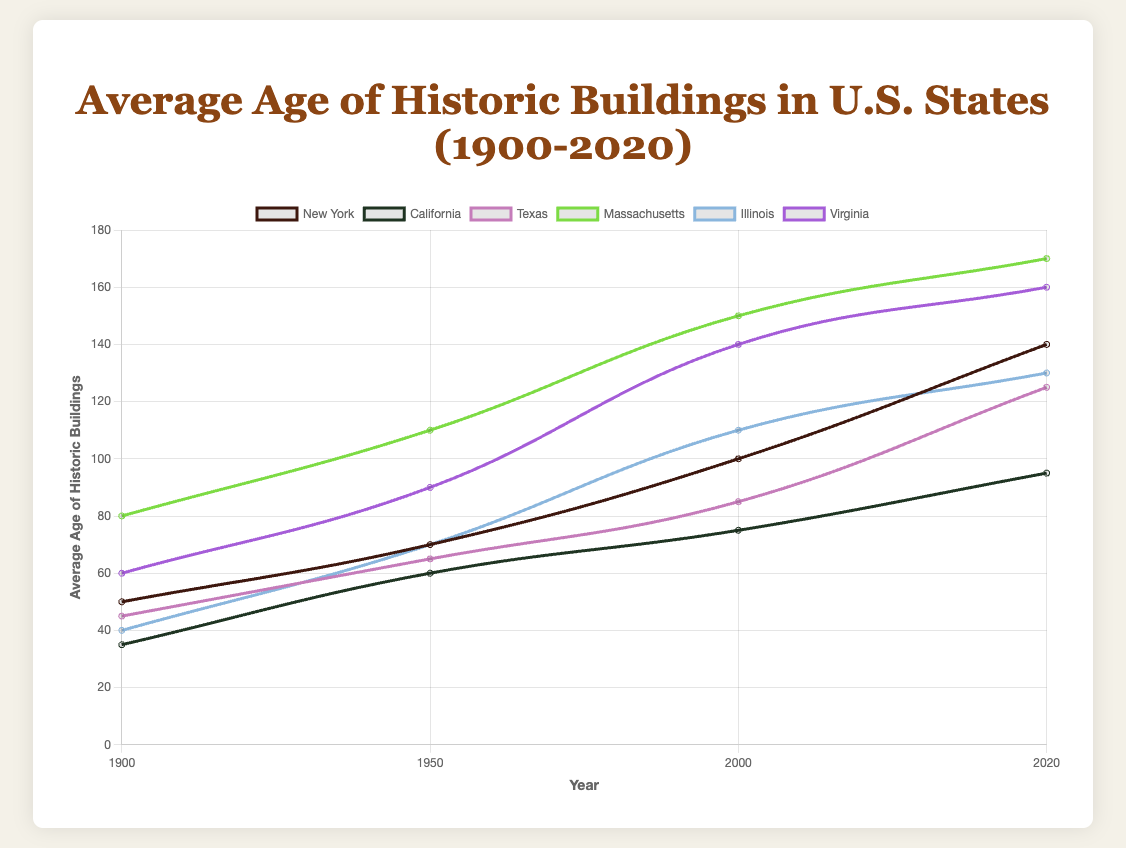What is the average age of historic buildings in New York in 2000? The figure shows a data point for New York in the year 2000, where the average age is marked.
Answer: 100 Which state had the oldest average age of historic buildings in 2020? By examining the data points for the year 2020 and comparing their values, Massachusetts has the highest value of 170.
Answer: Massachusetts How did the average age of historic buildings in Illinois change from 1900 to 2020? Look at the data points for Illinois in 1900 and then in 2020. The value changes from 40 to 130.
Answer: Increased by 90 Which state showed the most significant increase in the average age of historic buildings between 1900 and 2020? By looking at the difference in average ages from 1900 to 2020 for all states, New York increased from 50 to 140, which is an increase of 90, the largest among all states.
Answer: New York What is the difference in the average age of historic buildings between Massachusetts and California in 2020? For the year 2020, Massachusetts is at 170, and California is at 95. The difference is 170 - 95.
Answer: 75 How did the average age of historic buildings in Virginia evolve from 1950 to 2000? Check the data points for Virginia in 1950 and 2000. The average age grew from 90 to 140.
Answer: Increased by 50 Which state had the youngest average age of historic buildings in 1950? Looking at the data for 1950, California had the lowest average age of 60.
Answer: California What is the combined average age of historic buildings in Texas and New York in 2020? In 2020, Texas has an average age of 125, and New York has 140. The combined average is (125 + 140) / 2.
Answer: 132.5 Which state had the least change in the average age of historic buildings from 2000 to 2020? Calculate the difference for each state between 2000 and 2020 and identify the smallest. California changed from 75 to 95, a difference of 20, which is the smallest.
Answer: California Between 1900 and 1950, which state had the highest rate of increase in the average age of historic buildings? Calculate the rate of increase for each state between 1900 and 1950: (increase in average age) / (number of years). Massachusetts increased by 30 over 50 years, Texas increased by 20. The highest rate is for Massachusetts: 30/50 = 0.6.
Answer: Massachusetts 